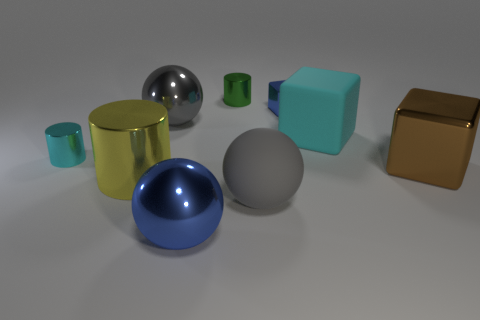What could be the size of these objects in relation to each other? The sizes of the objects vary, with some commonalities. The spheres and the cylinder seem to be of a consistent size, matching what might be small household decorative objects. The small green cube is much smaller, possibly a toy block, while the large aqua block and gold cube are significantly larger, possibly akin to storage boxes or oversized decorative pieces in a relative scale. 